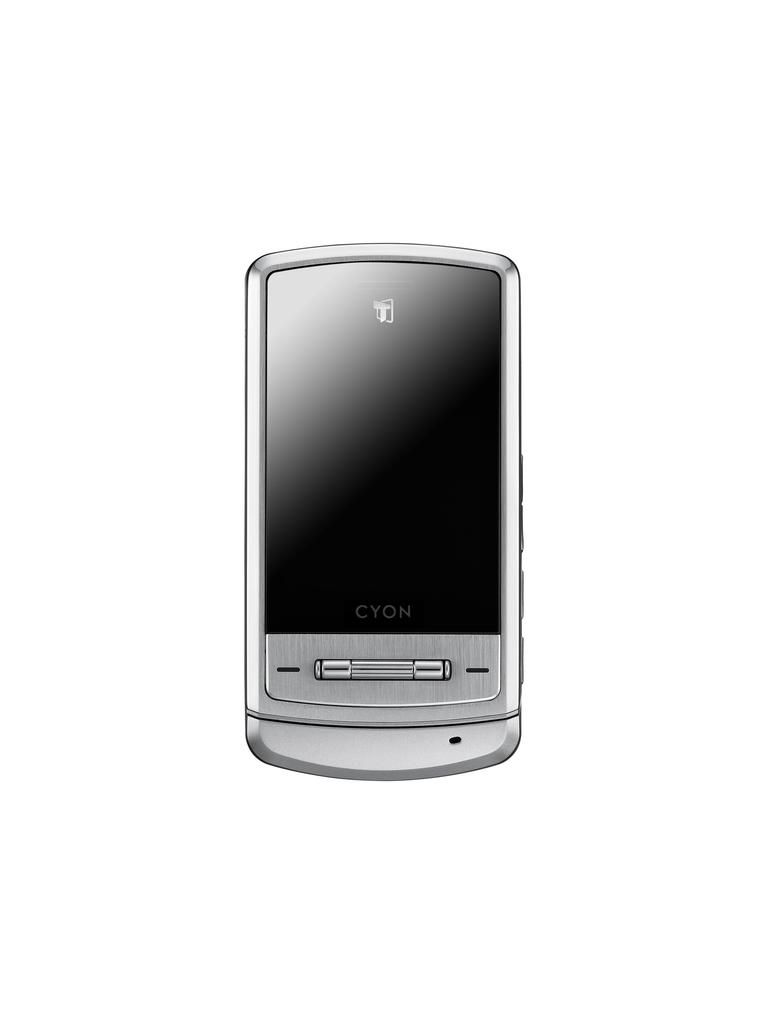Provide a one-sentence caption for the provided image. cyon brand cell phone that is the color silver turned off. 